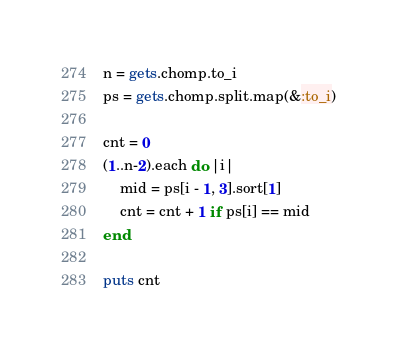Convert code to text. <code><loc_0><loc_0><loc_500><loc_500><_Ruby_>n = gets.chomp.to_i
ps = gets.chomp.split.map(&:to_i)

cnt = 0
(1..n-2).each do |i|
    mid = ps[i - 1, 3].sort[1]
    cnt = cnt + 1 if ps[i] == mid
end

puts cnt
</code> 